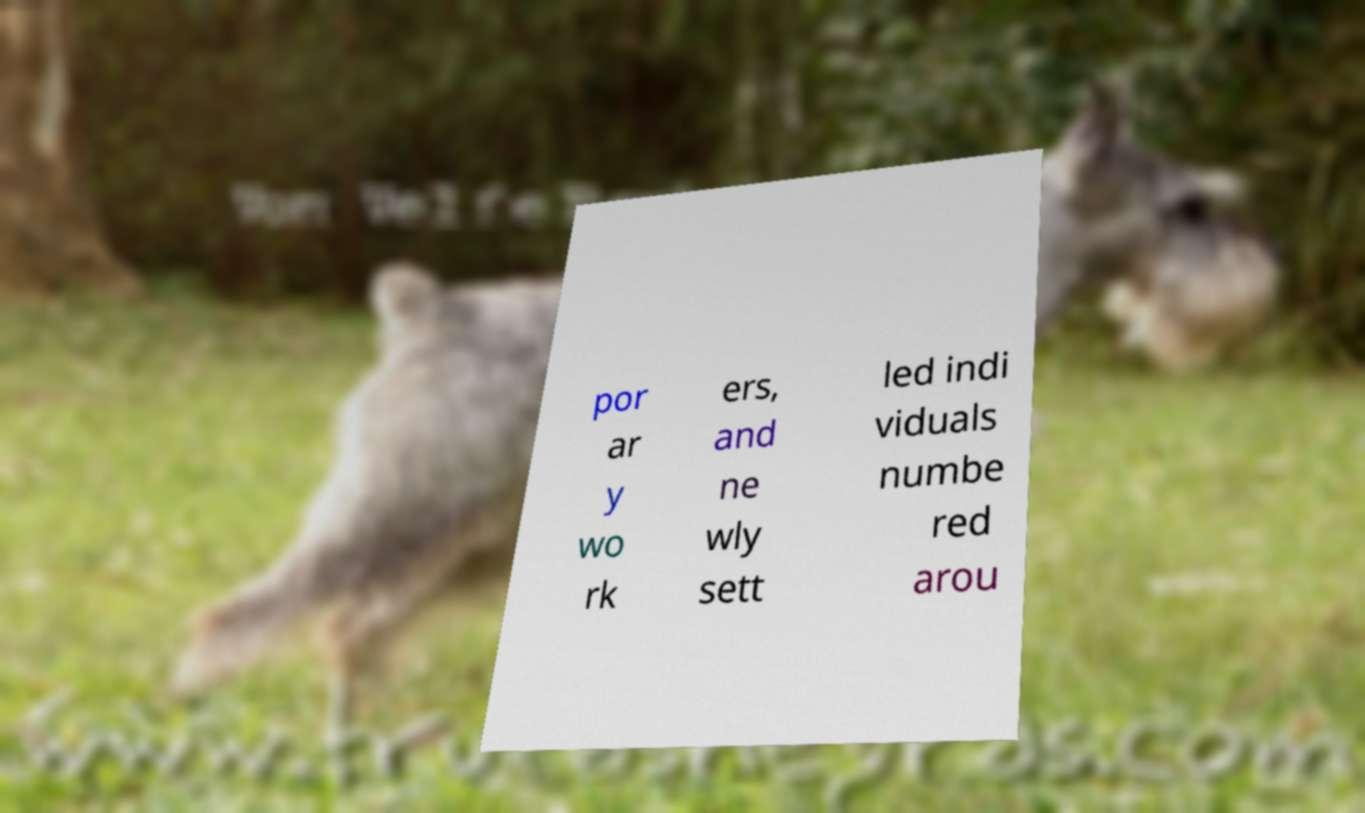Can you accurately transcribe the text from the provided image for me? por ar y wo rk ers, and ne wly sett led indi viduals numbe red arou 